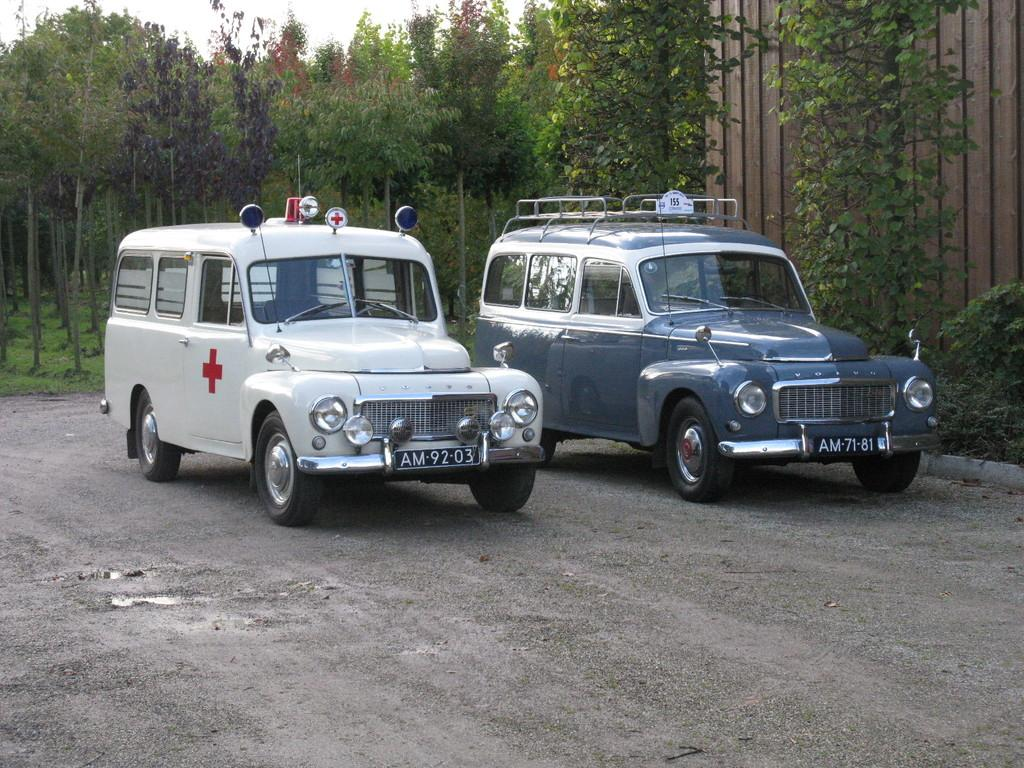How many vehicles can be seen on the road in the image? There are two vehicles on the road in the image. What is located on the right side of the image? There are trees and a wall on the right side of the image. What can be seen in the center of the background of the image? There are trees and grass in the center of the background of the image. What type of birthday celebration is happening in the image? There is no birthday celebration present in the image. How many bricks can be seen in the image? There is no mention of bricks in the image, so it is not possible to determine their number. 